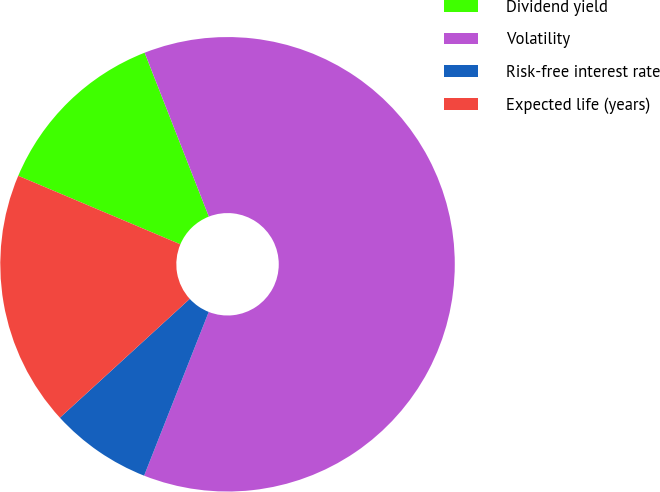Convert chart. <chart><loc_0><loc_0><loc_500><loc_500><pie_chart><fcel>Dividend yield<fcel>Volatility<fcel>Risk-free interest rate<fcel>Expected life (years)<nl><fcel>12.69%<fcel>61.92%<fcel>7.22%<fcel>18.16%<nl></chart> 